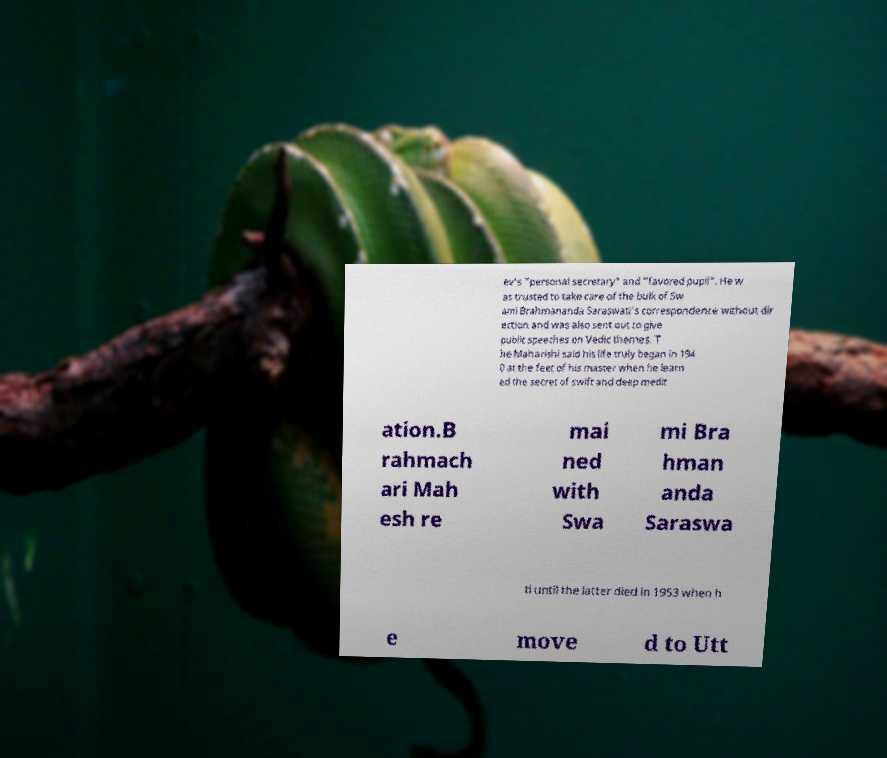Can you read and provide the text displayed in the image?This photo seems to have some interesting text. Can you extract and type it out for me? ev's "personal secretary" and "favored pupil". He w as trusted to take care of the bulk of Sw ami Brahmananda Saraswati's correspondence without dir ection and was also sent out to give public speeches on Vedic themes. T he Maharishi said his life truly began in 194 0 at the feet of his master when he learn ed the secret of swift and deep medit ation.B rahmach ari Mah esh re mai ned with Swa mi Bra hman anda Saraswa ti until the latter died in 1953 when h e move d to Utt 